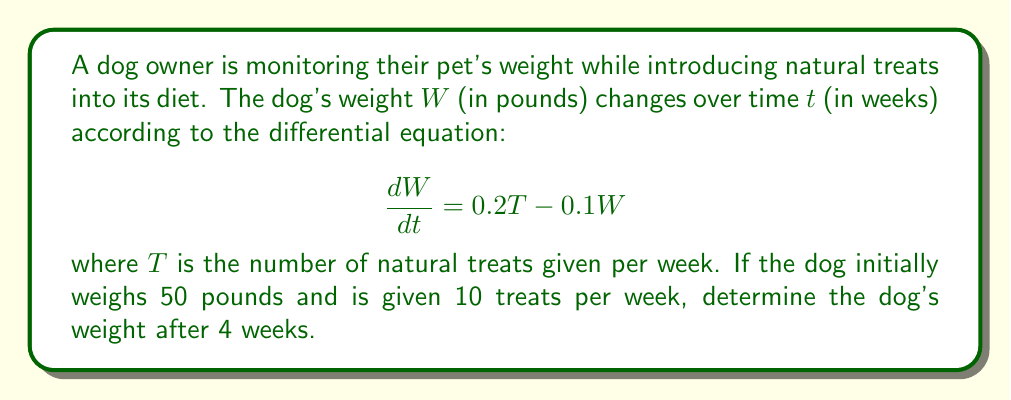Show me your answer to this math problem. To solve this problem, we need to use the method for solving first-order linear differential equations.

1) The general form of a first-order linear differential equation is:

   $$\frac{dy}{dx} + P(x)y = Q(x)$$

   In our case, $\frac{dW}{dt} + 0.1W = 0.2T$

2) The integrating factor is $e^{\int P(x)dx}$. Here, $P(t) = 0.1$, so the integrating factor is:

   $$e^{\int 0.1 dt} = e^{0.1t}$$

3) Multiply both sides of the equation by the integrating factor:

   $$e^{0.1t}\frac{dW}{dt} + 0.1e^{0.1t}W = 0.2Te^{0.1t}$$

4) The left side is now the derivative of $e^{0.1t}W$:

   $$\frac{d}{dt}(e^{0.1t}W) = 0.2Te^{0.1t}$$

5) Integrate both sides:

   $$e^{0.1t}W = \int 0.2Te^{0.1t}dt = 2Te^{0.1t} + C$$

6) Solve for W:

   $$W = 2T + Ce^{-0.1t}$$

7) Use the initial condition: When $t=0$, $W=50$:

   $$50 = 2(10) + C$$
   $$C = 30$$

8) The particular solution is:

   $$W = 20 + 30e^{-0.1t}$$

9) To find the weight after 4 weeks, substitute $t=4$:

   $$W = 20 + 30e^{-0.1(4)} = 20 + 30e^{-0.4} \approx 38.1$$
Answer: The dog's weight after 4 weeks will be approximately 38.1 pounds. 